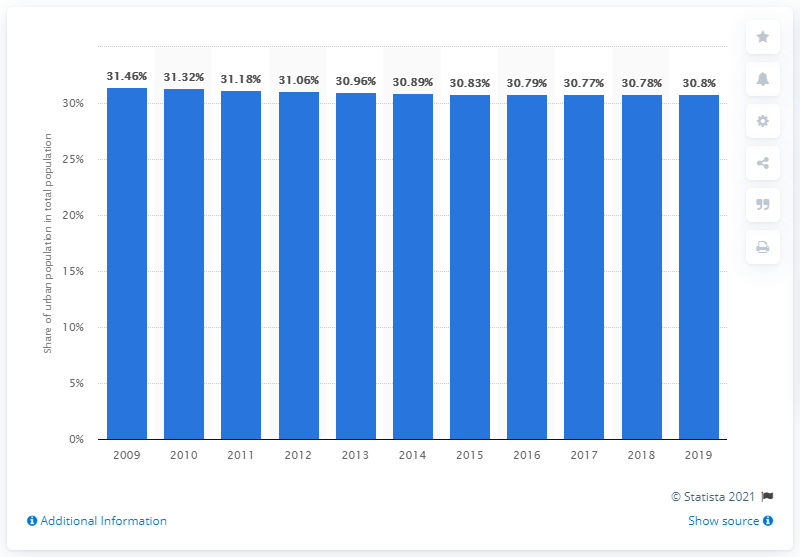Identify some key points in this picture. In 2019, approximately 30.8% of the population of St. Kitts and Nevis lived in urban areas and cities. 